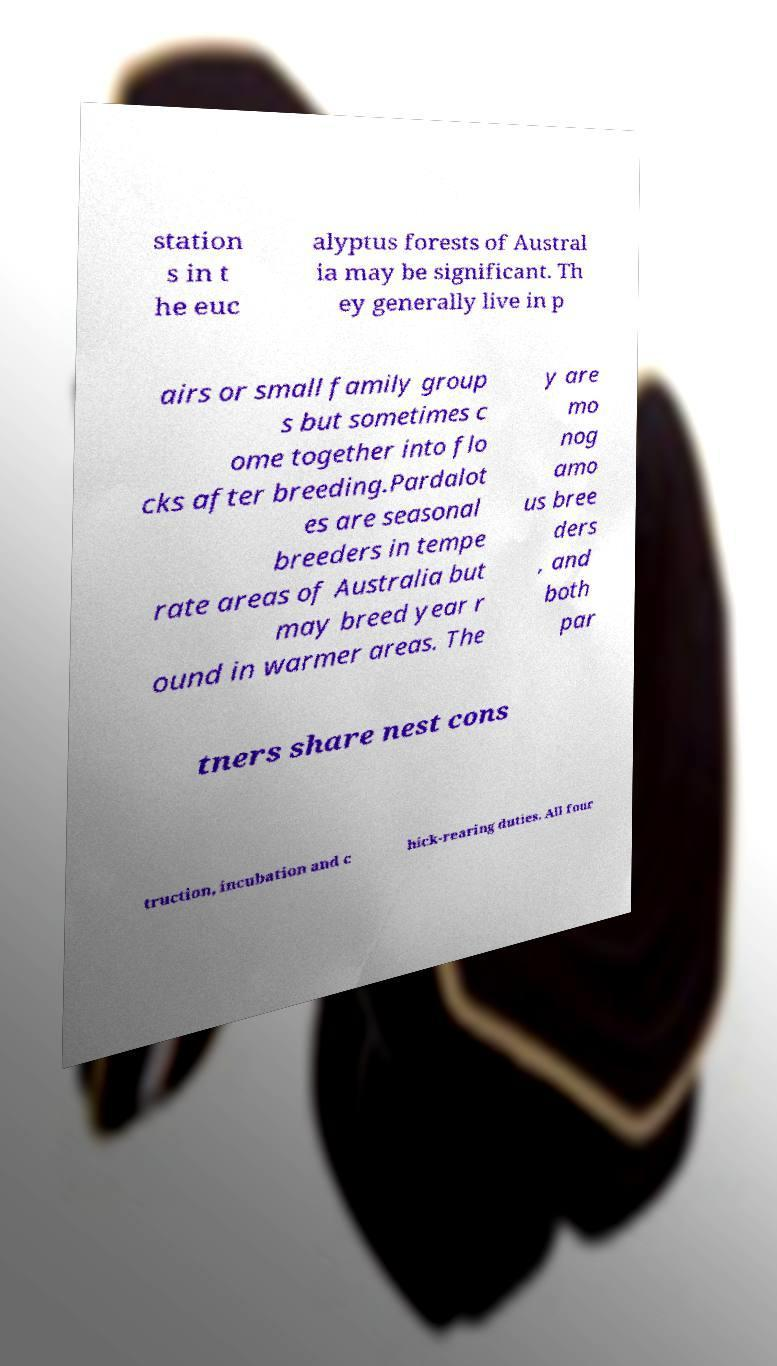Can you read and provide the text displayed in the image?This photo seems to have some interesting text. Can you extract and type it out for me? station s in t he euc alyptus forests of Austral ia may be significant. Th ey generally live in p airs or small family group s but sometimes c ome together into flo cks after breeding.Pardalot es are seasonal breeders in tempe rate areas of Australia but may breed year r ound in warmer areas. The y are mo nog amo us bree ders , and both par tners share nest cons truction, incubation and c hick-rearing duties. All four 